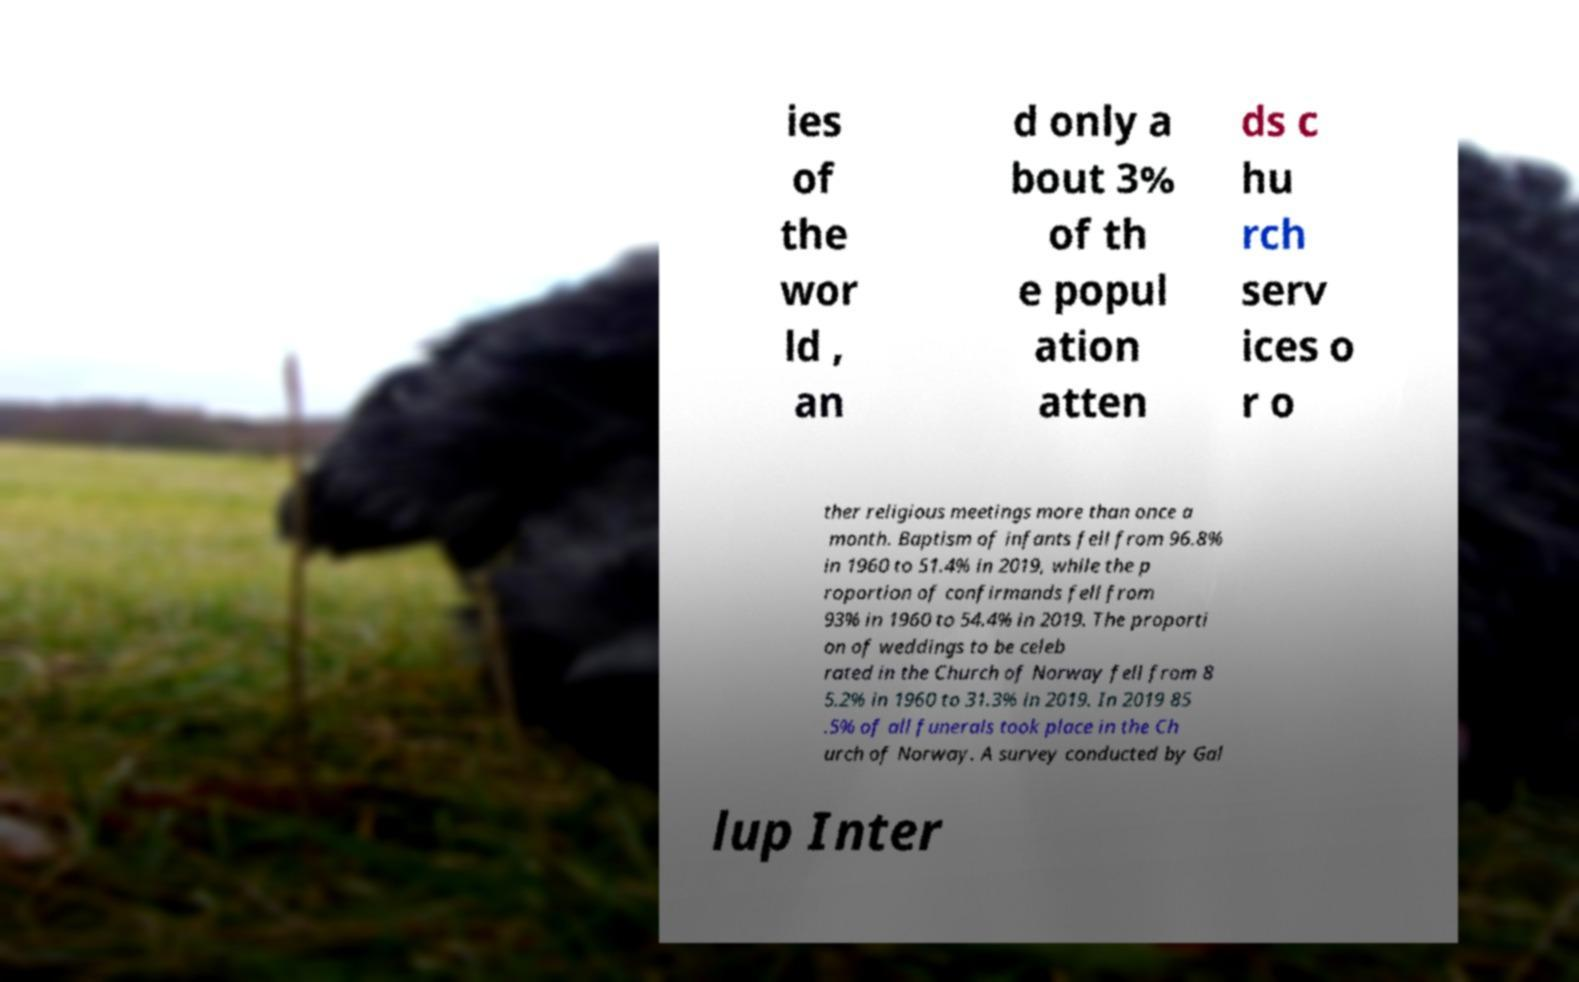There's text embedded in this image that I need extracted. Can you transcribe it verbatim? ies of the wor ld , an d only a bout 3% of th e popul ation atten ds c hu rch serv ices o r o ther religious meetings more than once a month. Baptism of infants fell from 96.8% in 1960 to 51.4% in 2019, while the p roportion of confirmands fell from 93% in 1960 to 54.4% in 2019. The proporti on of weddings to be celeb rated in the Church of Norway fell from 8 5.2% in 1960 to 31.3% in 2019. In 2019 85 .5% of all funerals took place in the Ch urch of Norway. A survey conducted by Gal lup Inter 